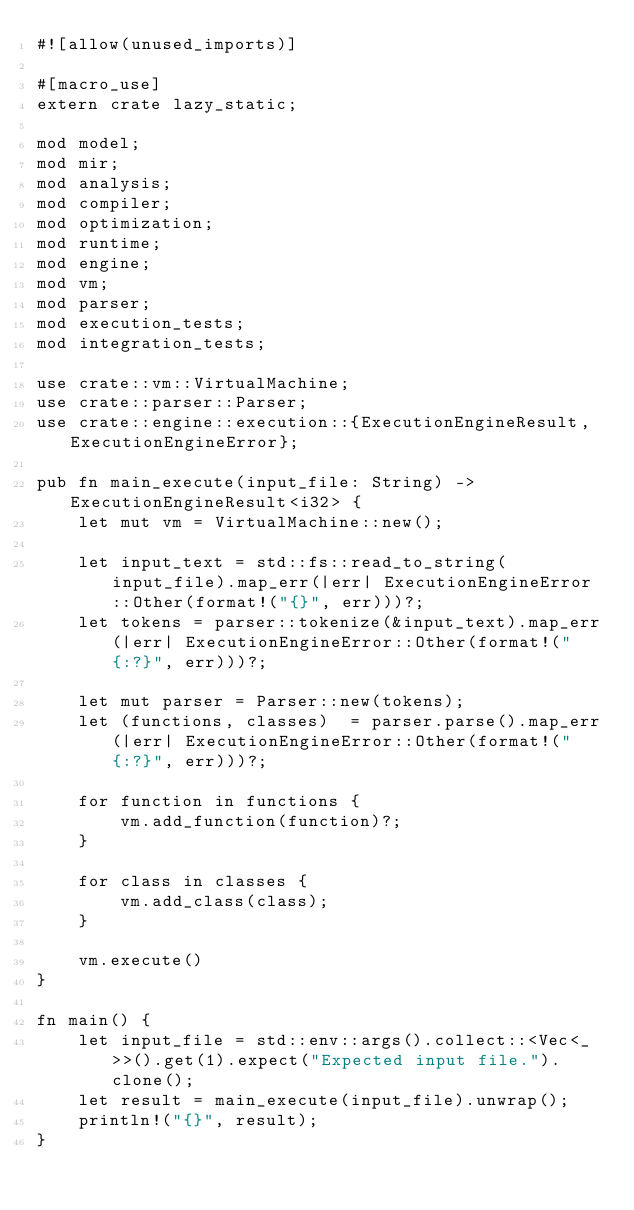<code> <loc_0><loc_0><loc_500><loc_500><_Rust_>#![allow(unused_imports)]

#[macro_use]
extern crate lazy_static;

mod model;
mod mir;
mod analysis;
mod compiler;
mod optimization;
mod runtime;
mod engine;
mod vm;
mod parser;
mod execution_tests;
mod integration_tests;

use crate::vm::VirtualMachine;
use crate::parser::Parser;
use crate::engine::execution::{ExecutionEngineResult, ExecutionEngineError};

pub fn main_execute(input_file: String) -> ExecutionEngineResult<i32> {
    let mut vm = VirtualMachine::new();

    let input_text = std::fs::read_to_string(input_file).map_err(|err| ExecutionEngineError::Other(format!("{}", err)))?;
    let tokens = parser::tokenize(&input_text).map_err(|err| ExecutionEngineError::Other(format!("{:?}", err)))?;

    let mut parser = Parser::new(tokens);
    let (functions, classes)  = parser.parse().map_err(|err| ExecutionEngineError::Other(format!("{:?}", err)))?;

    for function in functions {
        vm.add_function(function)?;
    }

    for class in classes {
        vm.add_class(class);
    }

    vm.execute()
}

fn main() {
    let input_file = std::env::args().collect::<Vec<_>>().get(1).expect("Expected input file.").clone();
    let result = main_execute(input_file).unwrap();
    println!("{}", result);
}
</code> 